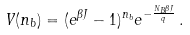<formula> <loc_0><loc_0><loc_500><loc_500>V ( n _ { b } ) = ( e ^ { \beta J } - 1 ) ^ { n _ { b } } e ^ { - \frac { N _ { B } \beta J } { q } } \, .</formula> 